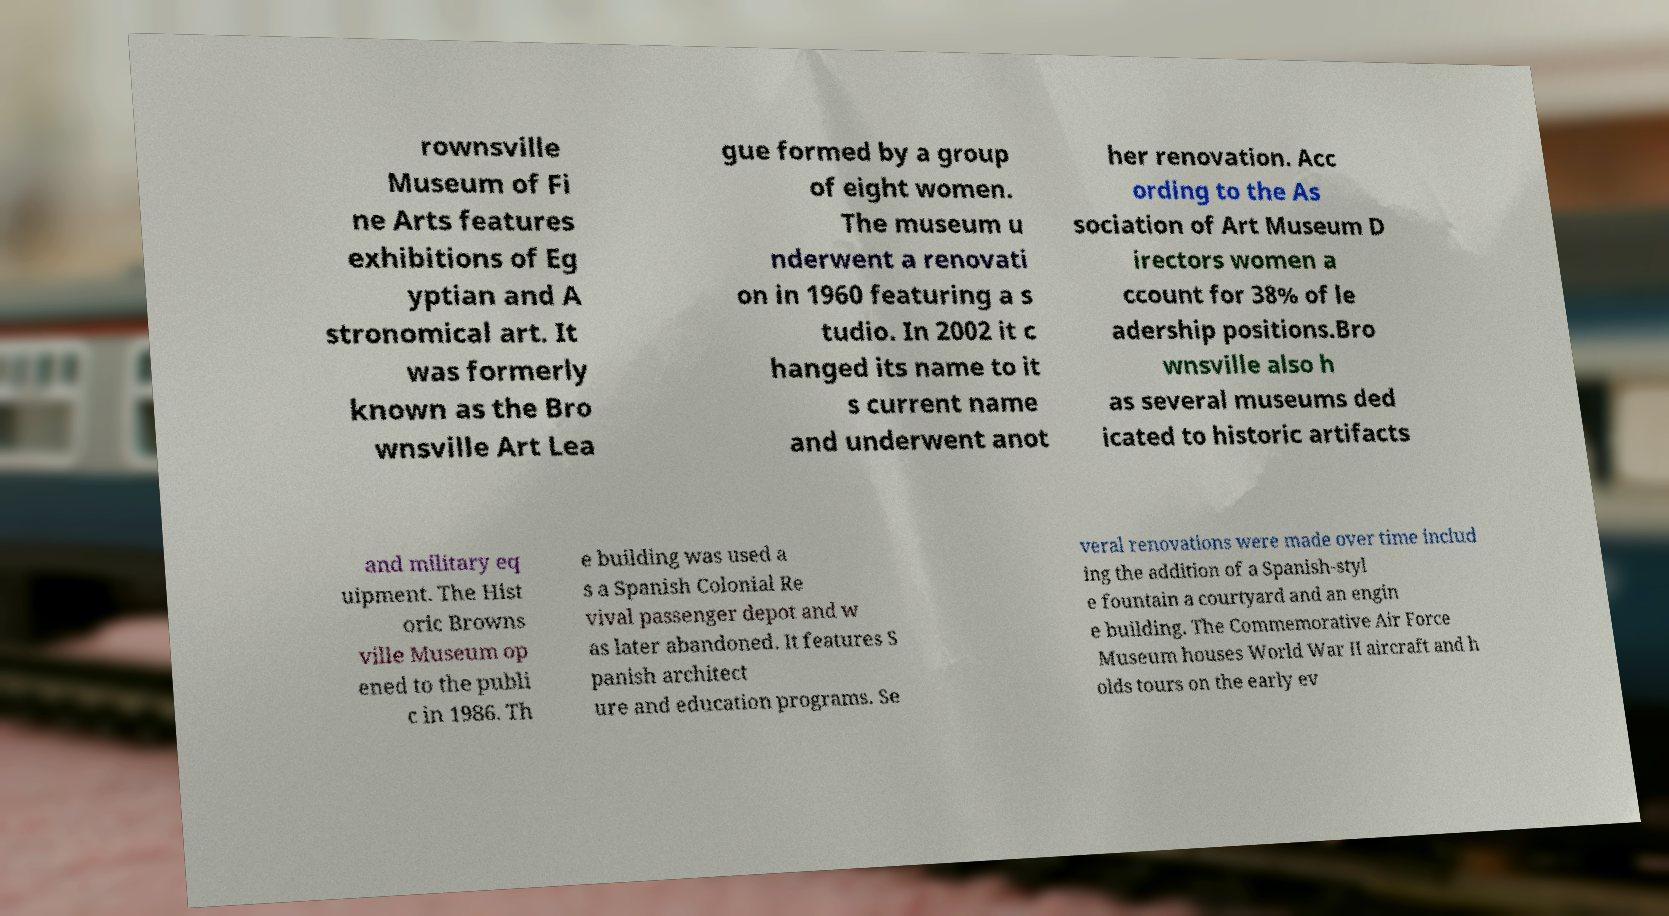Could you assist in decoding the text presented in this image and type it out clearly? rownsville Museum of Fi ne Arts features exhibitions of Eg yptian and A stronomical art. It was formerly known as the Bro wnsville Art Lea gue formed by a group of eight women. The museum u nderwent a renovati on in 1960 featuring a s tudio. In 2002 it c hanged its name to it s current name and underwent anot her renovation. Acc ording to the As sociation of Art Museum D irectors women a ccount for 38% of le adership positions.Bro wnsville also h as several museums ded icated to historic artifacts and military eq uipment. The Hist oric Browns ville Museum op ened to the publi c in 1986. Th e building was used a s a Spanish Colonial Re vival passenger depot and w as later abandoned. It features S panish architect ure and education programs. Se veral renovations were made over time includ ing the addition of a Spanish-styl e fountain a courtyard and an engin e building. The Commemorative Air Force Museum houses World War II aircraft and h olds tours on the early ev 